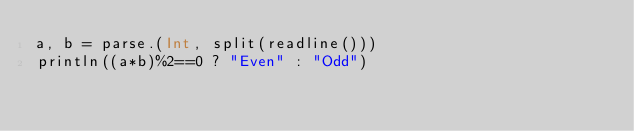<code> <loc_0><loc_0><loc_500><loc_500><_Julia_>a, b = parse.(Int, split(readline()))
println((a*b)%2==0 ? "Even" : "Odd")</code> 